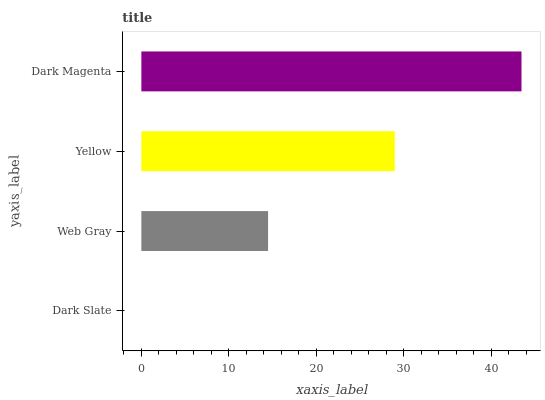Is Dark Slate the minimum?
Answer yes or no. Yes. Is Dark Magenta the maximum?
Answer yes or no. Yes. Is Web Gray the minimum?
Answer yes or no. No. Is Web Gray the maximum?
Answer yes or no. No. Is Web Gray greater than Dark Slate?
Answer yes or no. Yes. Is Dark Slate less than Web Gray?
Answer yes or no. Yes. Is Dark Slate greater than Web Gray?
Answer yes or no. No. Is Web Gray less than Dark Slate?
Answer yes or no. No. Is Yellow the high median?
Answer yes or no. Yes. Is Web Gray the low median?
Answer yes or no. Yes. Is Web Gray the high median?
Answer yes or no. No. Is Yellow the low median?
Answer yes or no. No. 